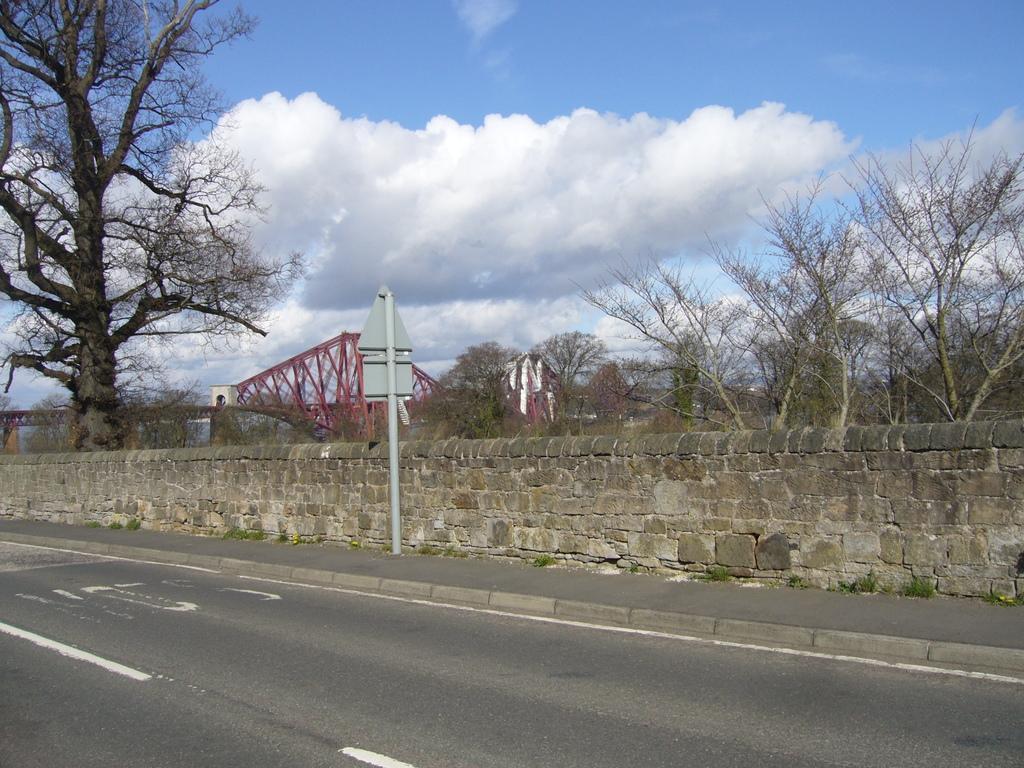Describe this image in one or two sentences. In this picture I can observe a wall. At the bottom I can see a road. In the background there are trees. At the top there are clouds in the sky. 